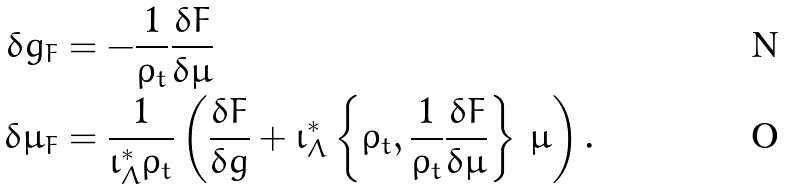Convert formula to latex. <formula><loc_0><loc_0><loc_500><loc_500>\delta g _ { F } & = - \frac { 1 } { \rho _ { t } } \frac { \delta F } { \delta \mu } \\ \delta \mu _ { F } & = \frac { 1 } { \iota _ { \Lambda } ^ { * } \rho _ { t } } \left ( \frac { \delta F } { \delta g } + \iota _ { \Lambda } ^ { * } \left \{ \rho _ { t } , \frac { 1 } { \rho _ { t } } \frac { \delta F } { \delta \mu } \right \} \, \mu \right ) .</formula> 